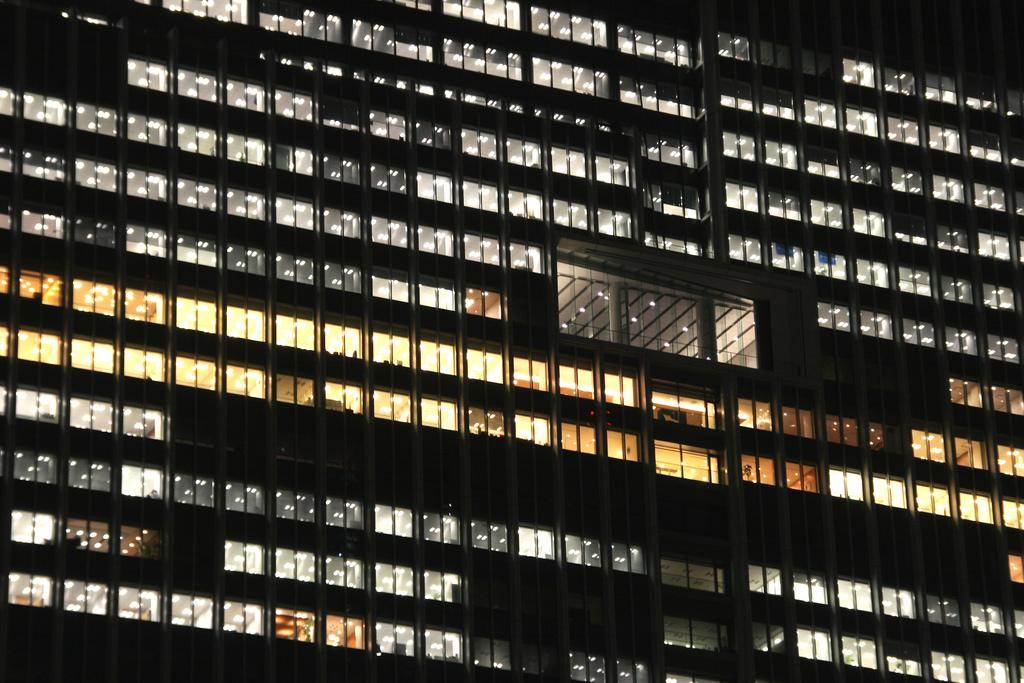What type of structure is present in the image? There is a building in the image. What feature can be seen on the building? There are glass windows on the building. What else is visible in the image besides the building? There are lights visible in the image. What type of doll is being crushed by the building in the image? There is no doll present in the image, nor is there any indication of a doll being crushed by the building. 